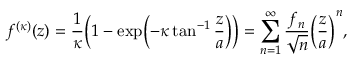Convert formula to latex. <formula><loc_0><loc_0><loc_500><loc_500>f ^ { ( \kappa ) } ( z ) = \frac { 1 } { \kappa } \left ( 1 - \exp \left ( - \kappa \tan ^ { - 1 } \frac { z } { a } \right ) \right ) = \sum _ { n = 1 } ^ { \infty } \frac { f _ { n } } { \sqrt { n } } \left ( \frac { z } { a } \right ) ^ { n } ,</formula> 